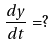Convert formula to latex. <formula><loc_0><loc_0><loc_500><loc_500>\frac { d y } { d t } = ?</formula> 